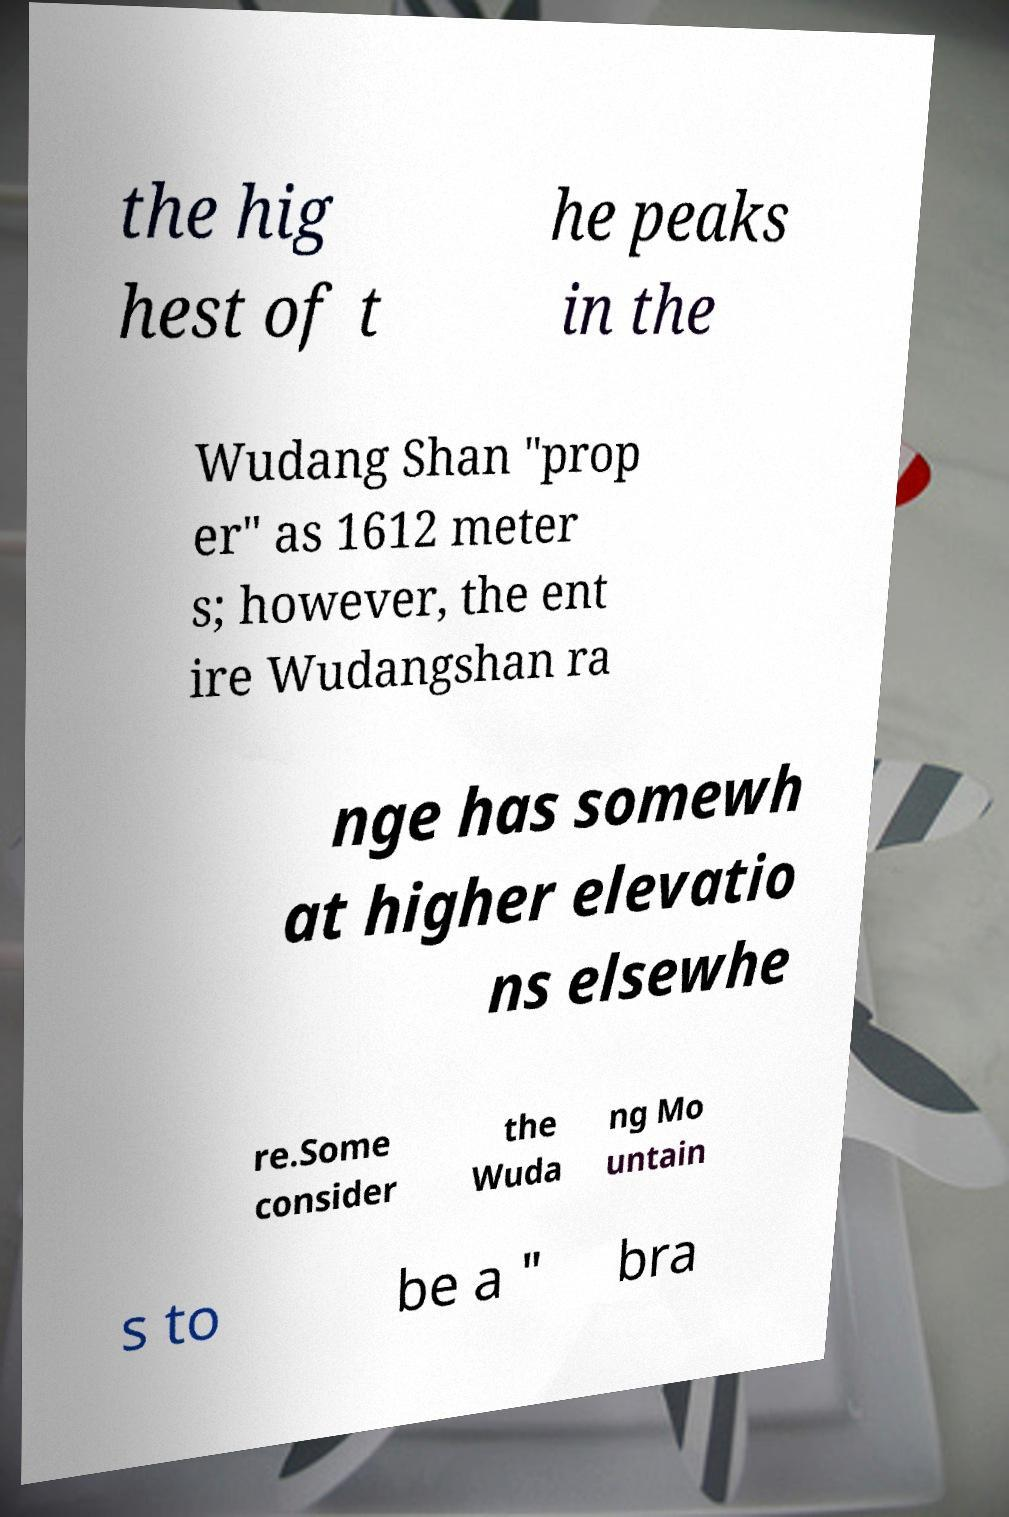What messages or text are displayed in this image? I need them in a readable, typed format. the hig hest of t he peaks in the Wudang Shan "prop er" as 1612 meter s; however, the ent ire Wudangshan ra nge has somewh at higher elevatio ns elsewhe re.Some consider the Wuda ng Mo untain s to be a " bra 